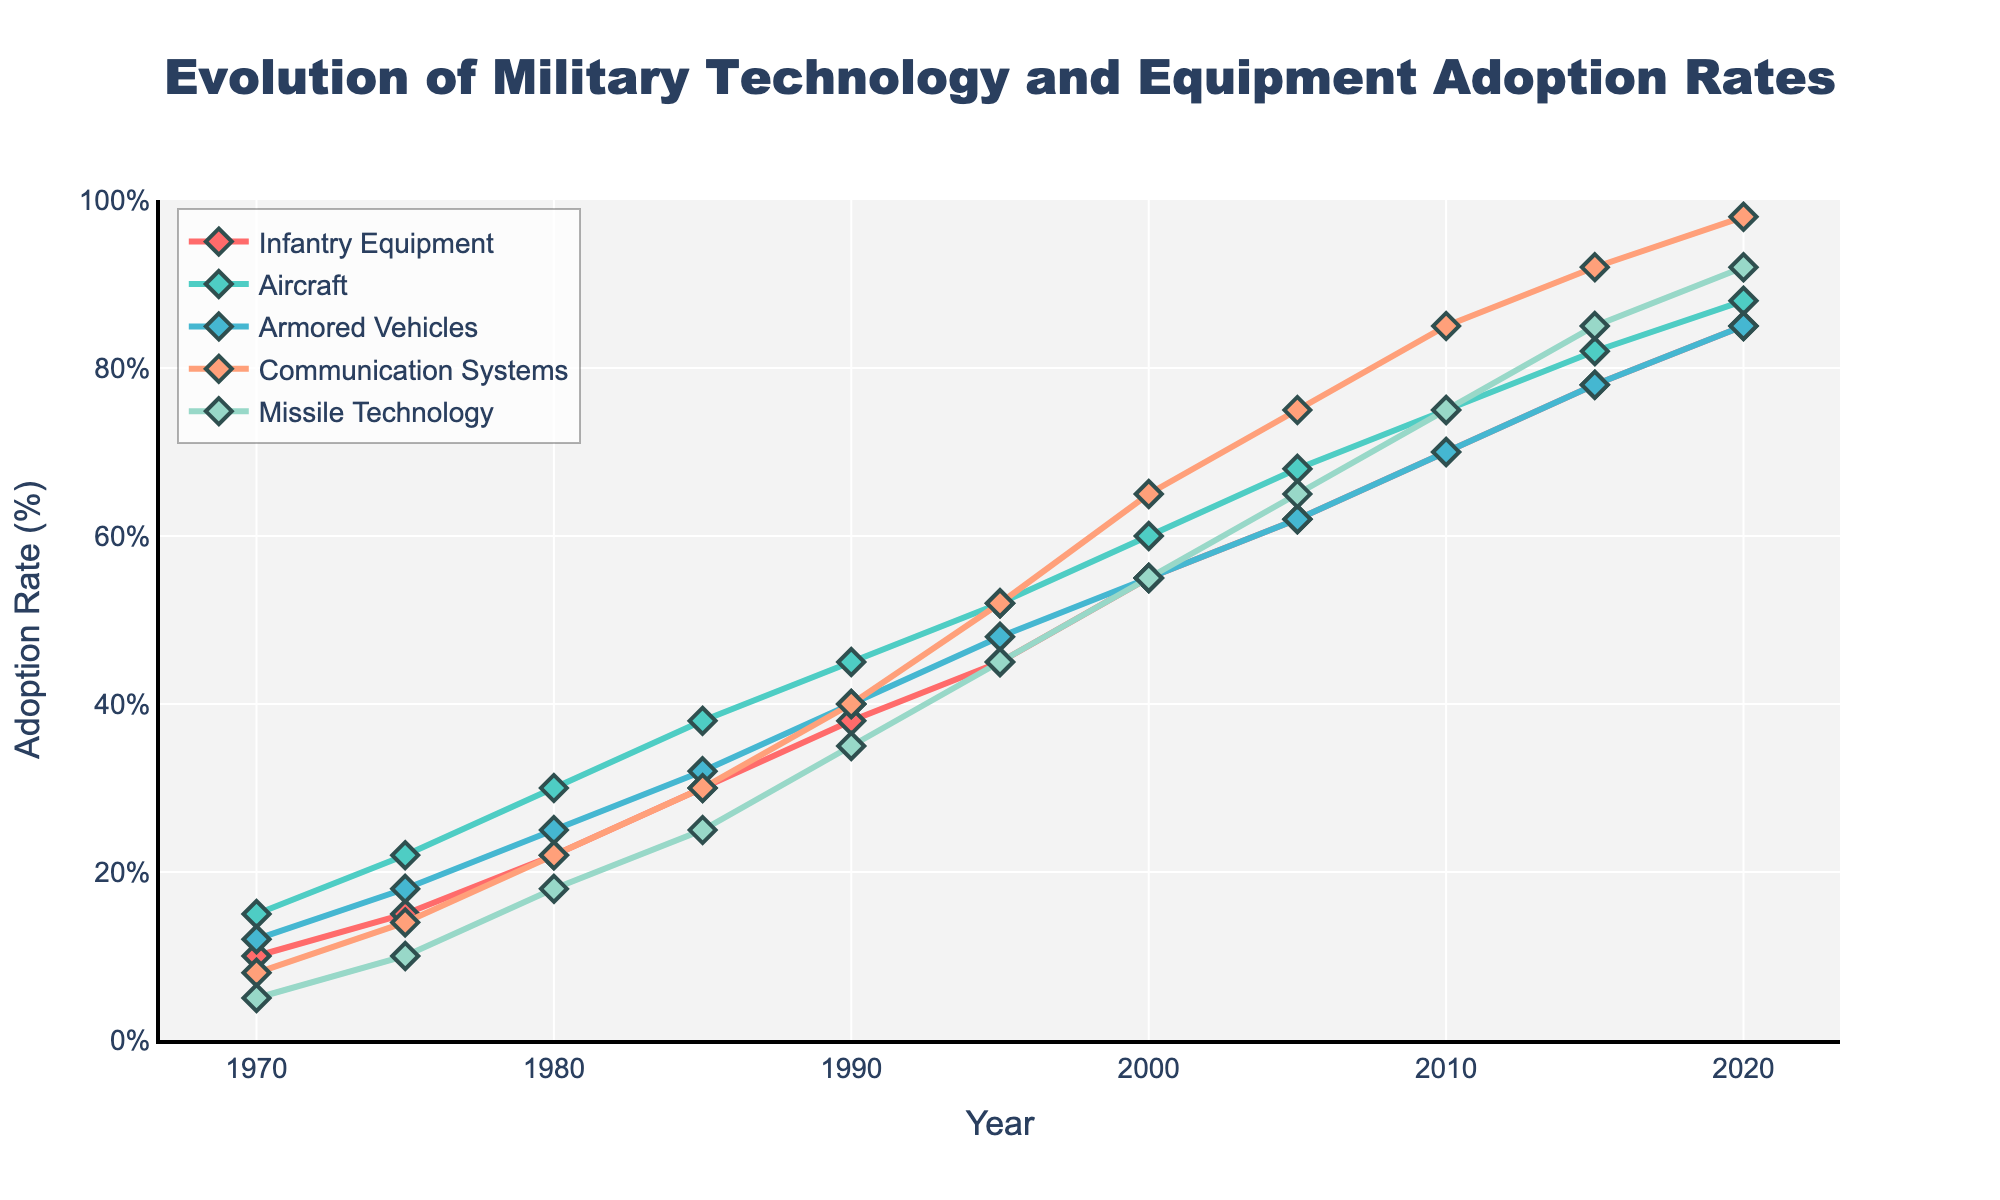What is the general trend in the adoption rate of missile technology from 1970 to 2020? The adoption rate of missile technology shows a clear upward trend. Starting from 5% in 1970, it steadily increases over the years to reach 92% by 2020.
Answer: Upward trend Which category experienced the greatest increase in adoption rate from 1970 to 2020? By calculating the difference for each category from 1970 to 2020, we get: Infantry Equipment (85-10=75), Aircraft (88-15=73), Armored Vehicles (85-12=73), Communication Systems (98-8=90), Missile Technology (92-5=87). Thus, Communication Systems had the greatest increase (90%).
Answer: Communication Systems What was the adoption rate of Communication Systems in 1985, and how does it compare to the adoption rate of Armored Vehicles in the same year? In 1985, the adoption rate of Communication Systems was 30%, while the adoption rate for Armored Vehicles was also 30%. The adoption rates were the same for both categories in that year.
Answer: Same By how much did the adoption rate of Aircraft increase between 1990 and 2015? The adoption rate of Aircraft in 1990 was 45%, and in 2015 it was 82%. The difference is 82% - 45% = 37%. So, it increased by 37%.
Answer: 37% Which year marks the start of the steeper increase in adoption rates for Communication Systems? The adoption rate for Communication Systems starts increasing more steeply around 1995, moving from 40% in 1990 to 52%, and then continues on a steeper slope till 2020.
Answer: 1995 In which decade did Infantry Equipment see the highest percentage increase in adoption rate? The decades and their increases are: 1970-1980 (22-10=12), 1980-1990 (38-22=16), 1990-2000 (55-38=17), 2000-2010 (70-55=15), 2010-2020 (85-70=15). The highest increase is from 1990-2000.
Answer: 1990-2000 If you were to average the adoption rates of Armored Vehicles and Missile Technology in 2010, what would it be? In 2010, the adoption rate of Armored Vehicles was 70% and Missile Technology was 75%. The average is (70+75)/2 = 72.5%.
Answer: 72.5% Which technology had the lowest adoption rate in 1970 and what was its value? In 1970, the technology with the lowest adoption rate was Missile Technology, with a value of 5%.
Answer: Missile Technology, 5% Between which two consecutive years did Missile Technology see the greatest absolute increase in adoption rate? By checking the differences between consecutive years: 
1970-1975 (10-5=5), 1975-1980 (18-10=8), 1980-1985 (25-18=7), 1985-1990 (35-25=10), 1990-1995 (45-35=10), 1995-2000 (55-45=10), 2000-2005 (65-55=10), 2005-2010 (75-65=10), 2010-2015 (85-75=10), 2015-2020 (92-85=7). Hence, the greatest increase is between the years 1985-1990, and 1990-1995, 1995-2000, 2000-2005, 2005-2010, each with an increase of 10.
Answer: 1985-1990, 1990-1995, 1995-2000, 2000-2005, 2005-2010 What visual attribute is unique to the line representing Missile Technology? The line representing Missile Technology is visually differentiated by its distinct color which is green.
Answer: Green 